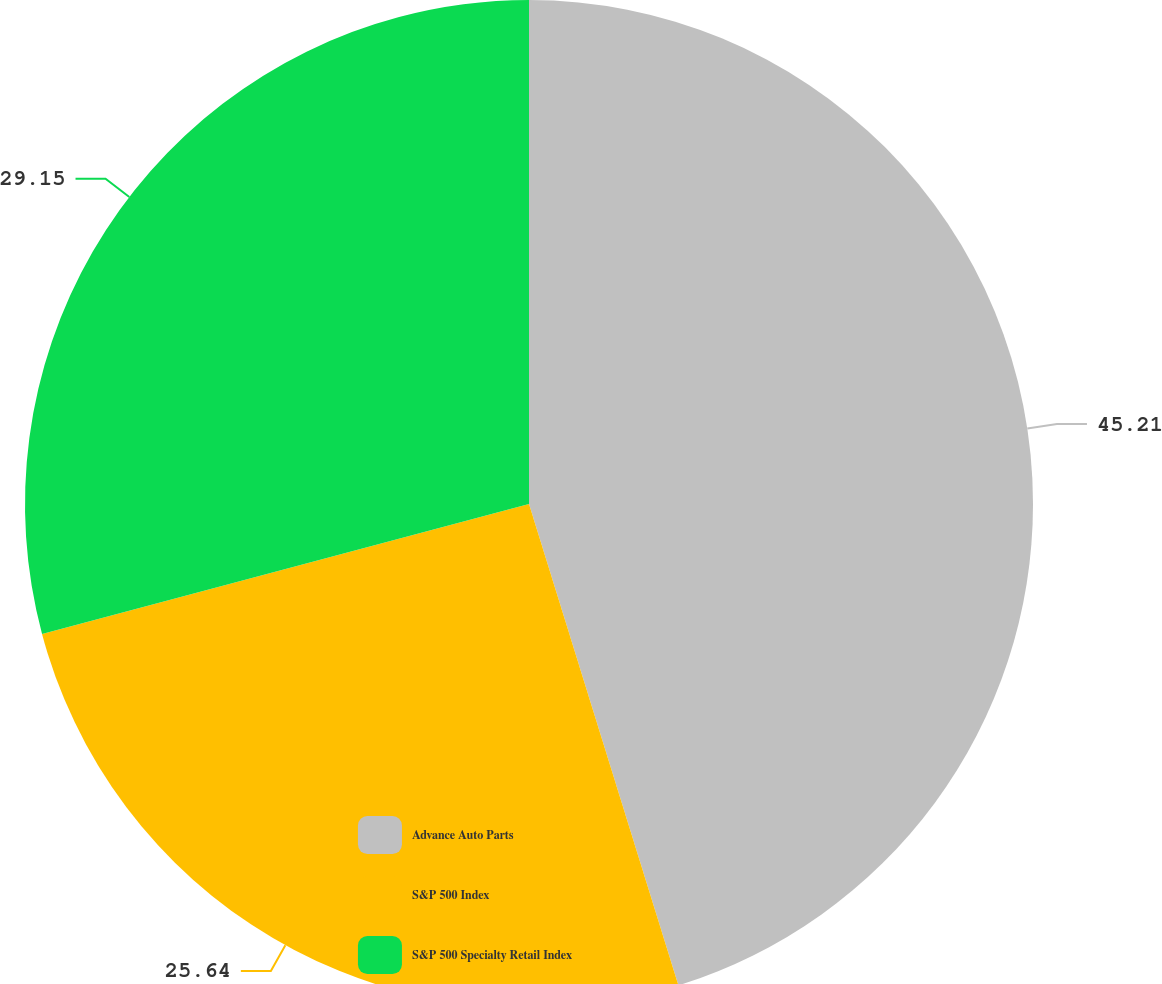Convert chart to OTSL. <chart><loc_0><loc_0><loc_500><loc_500><pie_chart><fcel>Advance Auto Parts<fcel>S&P 500 Index<fcel>S&P 500 Specialty Retail Index<nl><fcel>45.21%<fcel>25.64%<fcel>29.15%<nl></chart> 